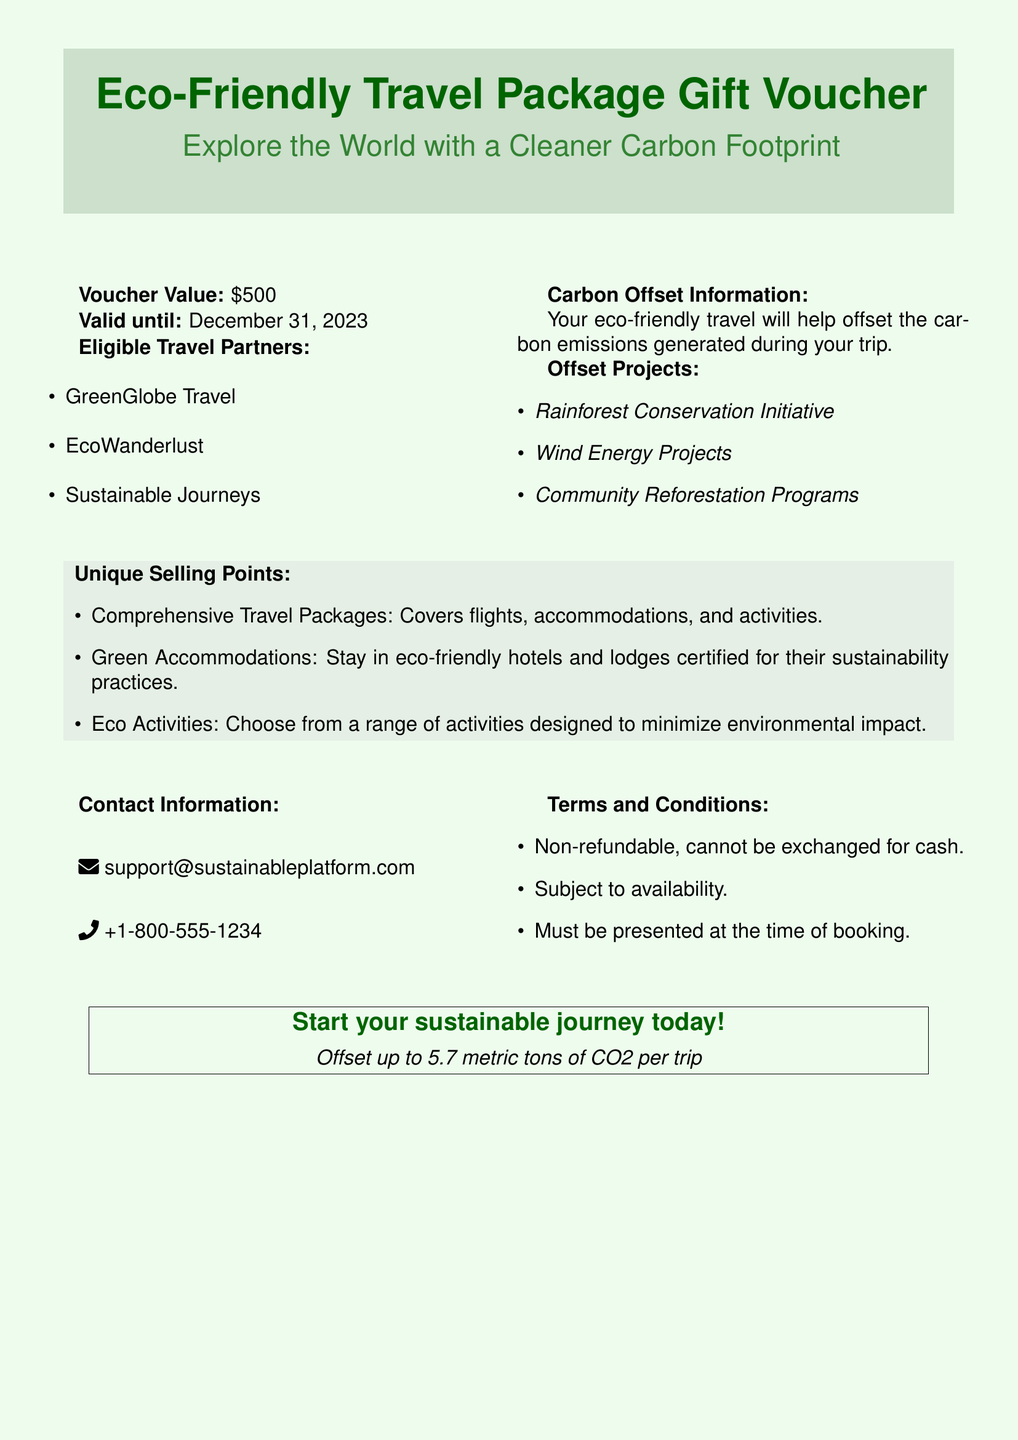What is the voucher value? The voucher value is specified in the document and is $500.
Answer: $500 When is the voucher valid until? The document states that the voucher is valid until December 31, 2023.
Answer: December 31, 2023 Which travel partners are eligible? The document lists three travel partners: GreenGlobe Travel, EcoWanderlust, and Sustainable Journeys.
Answer: GreenGlobe Travel, EcoWanderlust, Sustainable Journeys What is the maximum carbon offset per trip? The document specifies that the offset can be up to 5.7 metric tons of CO2 per trip.
Answer: 5.7 metric tons What type of travel packages does the voucher cover? The voucher covers comprehensive travel packages that include flights, accommodations, and activities.
Answer: Flights, accommodations, and activities Are the vouchers refundable? The document mentions that the vouchers are non-refundable.
Answer: Non-refundable What types of offset projects are included? The document lists three types of offset projects: Rainforest Conservation Initiative, Wind Energy Projects, and Community Reforestation Programs.
Answer: Rainforest Conservation Initiative, Wind Energy Projects, Community Reforestation Programs What is the contact email for support? The document provides the contact email for support as support@sustainableplatform.com.
Answer: support@sustainableplatform.com What must be presented at the time of booking? The document states that the voucher must be presented at the time of booking.
Answer: The voucher 